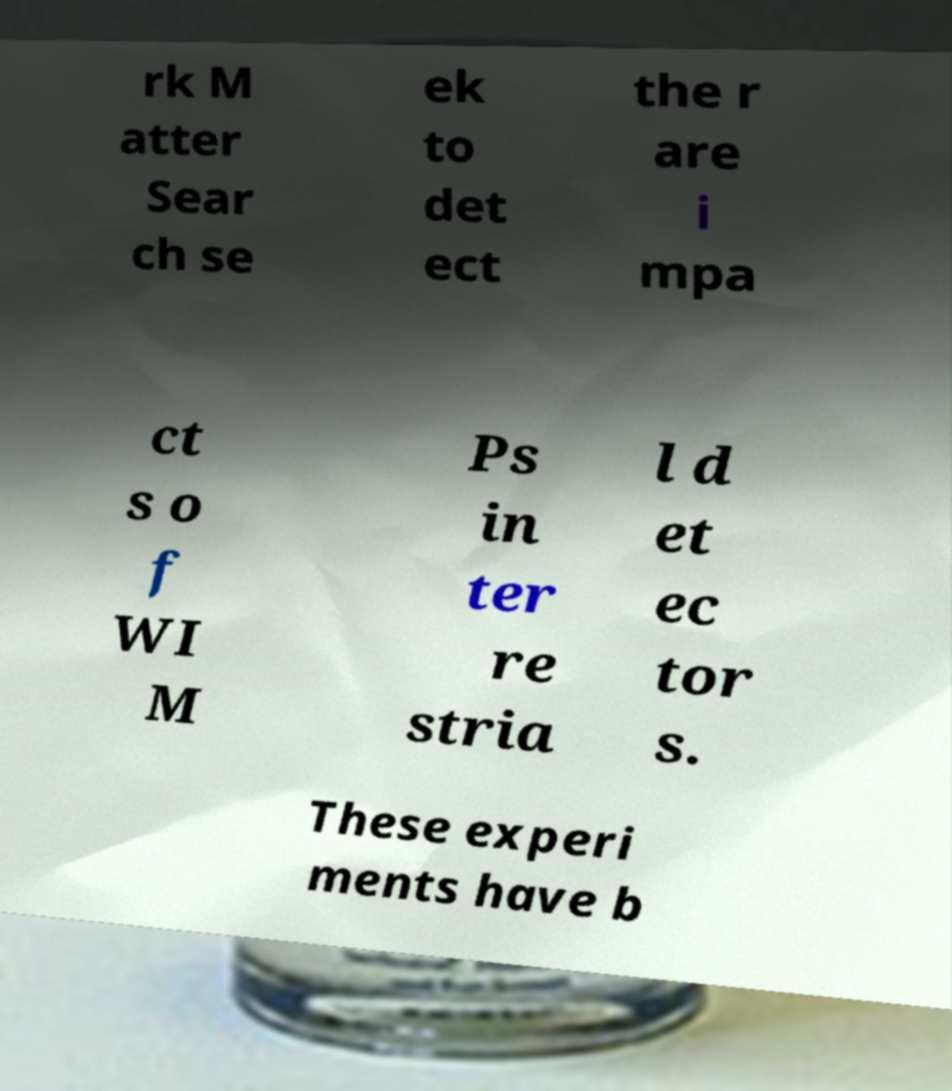Could you extract and type out the text from this image? rk M atter Sear ch se ek to det ect the r are i mpa ct s o f WI M Ps in ter re stria l d et ec tor s. These experi ments have b 